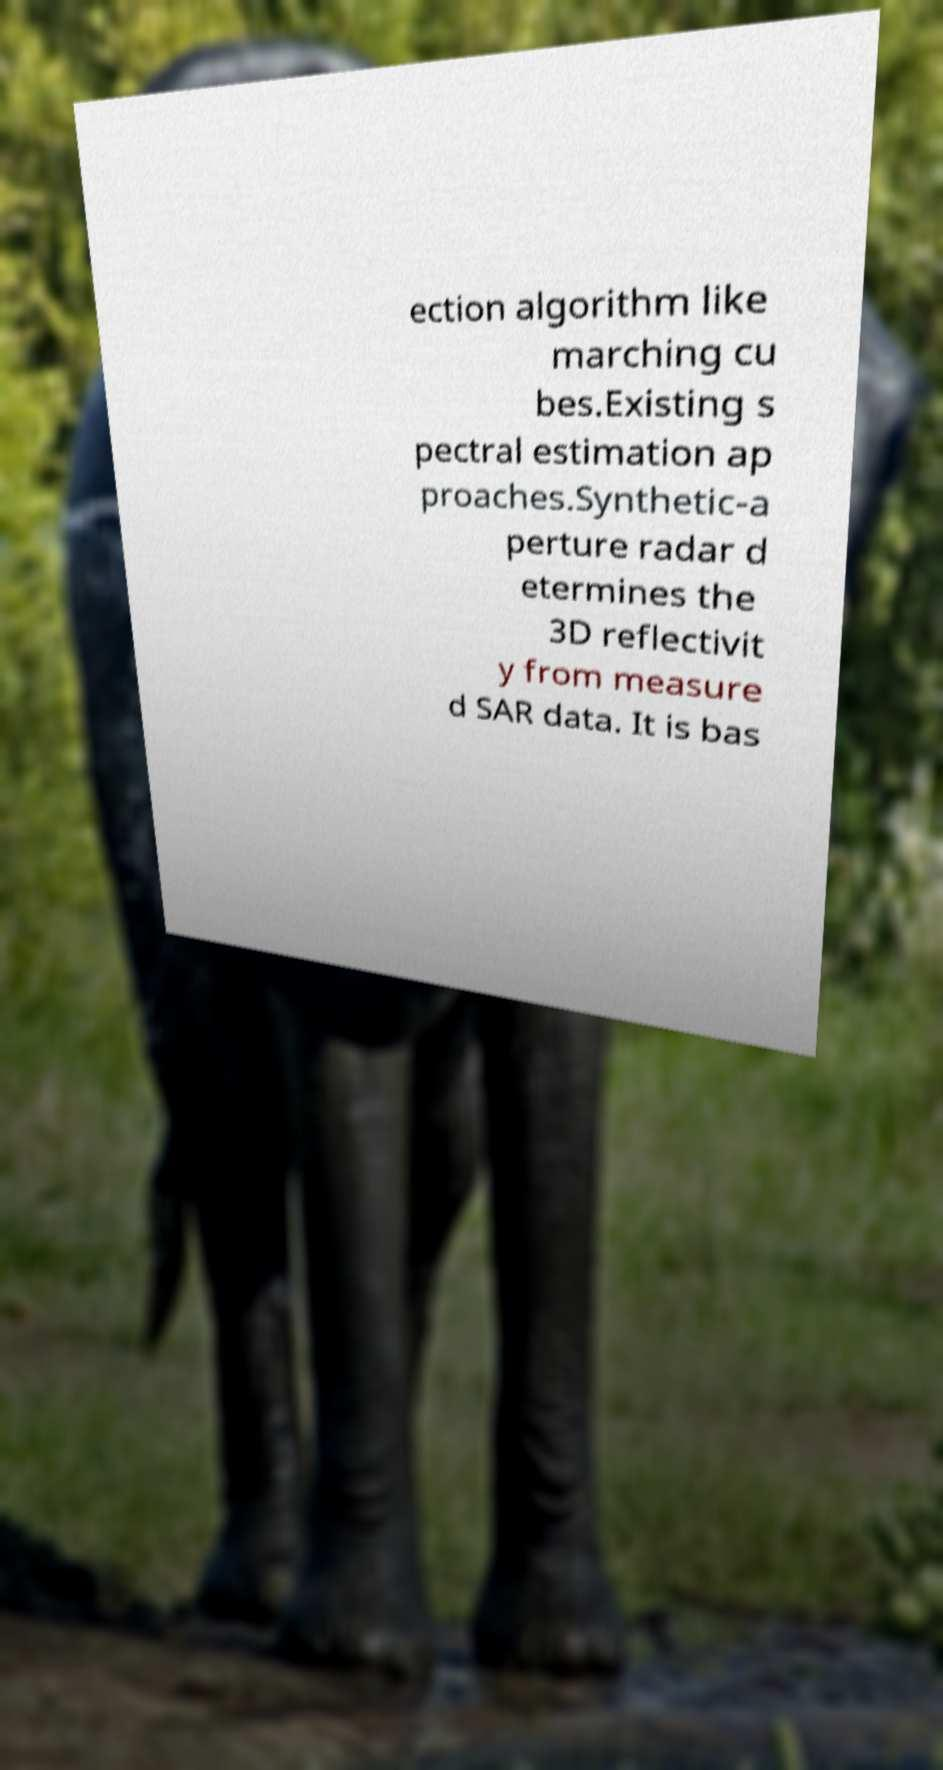Can you read and provide the text displayed in the image?This photo seems to have some interesting text. Can you extract and type it out for me? ection algorithm like marching cu bes.Existing s pectral estimation ap proaches.Synthetic-a perture radar d etermines the 3D reflectivit y from measure d SAR data. It is bas 